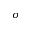Convert formula to latex. <formula><loc_0><loc_0><loc_500><loc_500>\sigma</formula> 